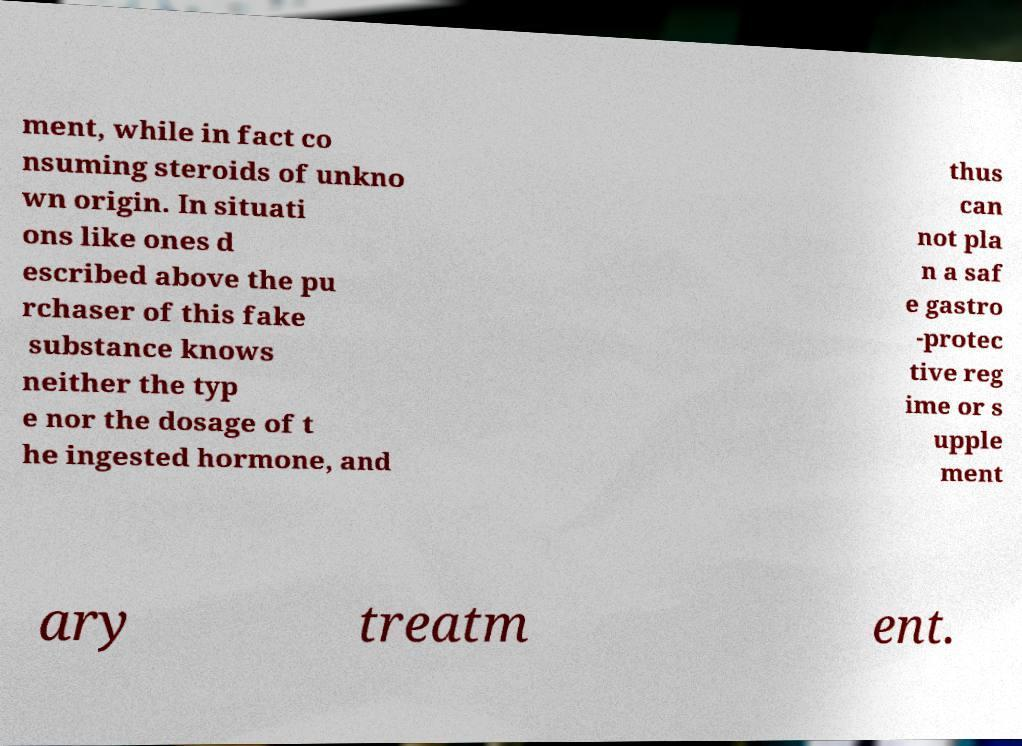There's text embedded in this image that I need extracted. Can you transcribe it verbatim? ment, while in fact co nsuming steroids of unkno wn origin. In situati ons like ones d escribed above the pu rchaser of this fake substance knows neither the typ e nor the dosage of t he ingested hormone, and thus can not pla n a saf e gastro -protec tive reg ime or s upple ment ary treatm ent. 